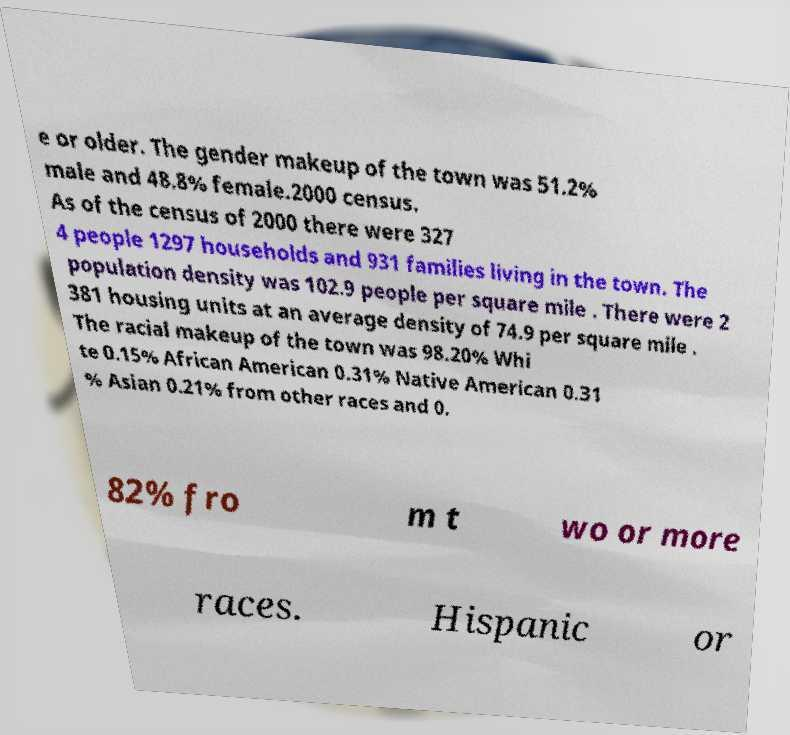What messages or text are displayed in this image? I need them in a readable, typed format. e or older. The gender makeup of the town was 51.2% male and 48.8% female.2000 census. As of the census of 2000 there were 327 4 people 1297 households and 931 families living in the town. The population density was 102.9 people per square mile . There were 2 381 housing units at an average density of 74.9 per square mile . The racial makeup of the town was 98.20% Whi te 0.15% African American 0.31% Native American 0.31 % Asian 0.21% from other races and 0. 82% fro m t wo or more races. Hispanic or 